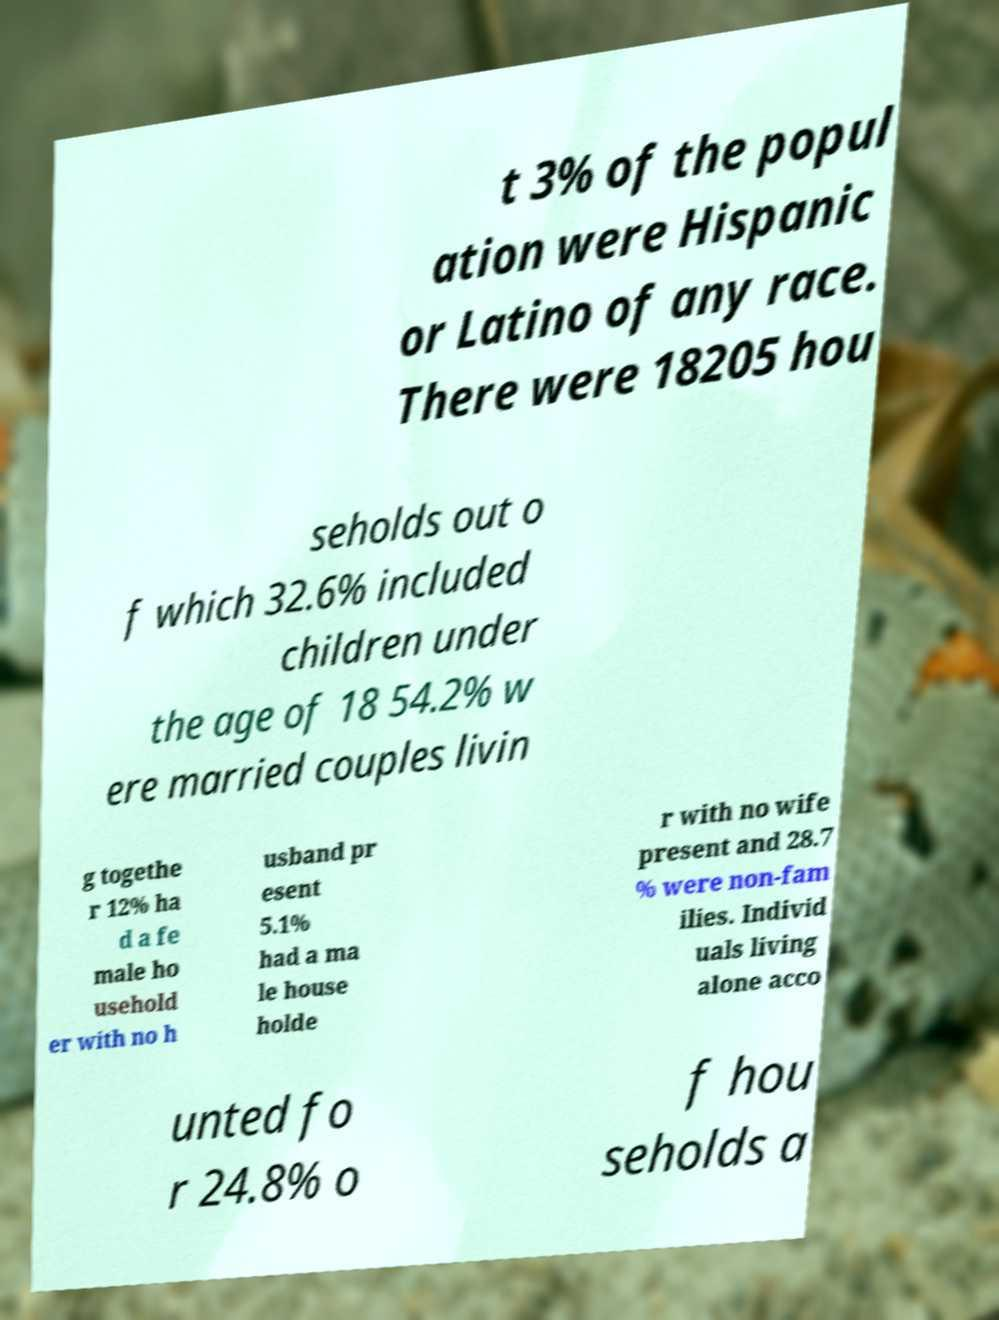Can you read and provide the text displayed in the image?This photo seems to have some interesting text. Can you extract and type it out for me? t 3% of the popul ation were Hispanic or Latino of any race. There were 18205 hou seholds out o f which 32.6% included children under the age of 18 54.2% w ere married couples livin g togethe r 12% ha d a fe male ho usehold er with no h usband pr esent 5.1% had a ma le house holde r with no wife present and 28.7 % were non-fam ilies. Individ uals living alone acco unted fo r 24.8% o f hou seholds a 